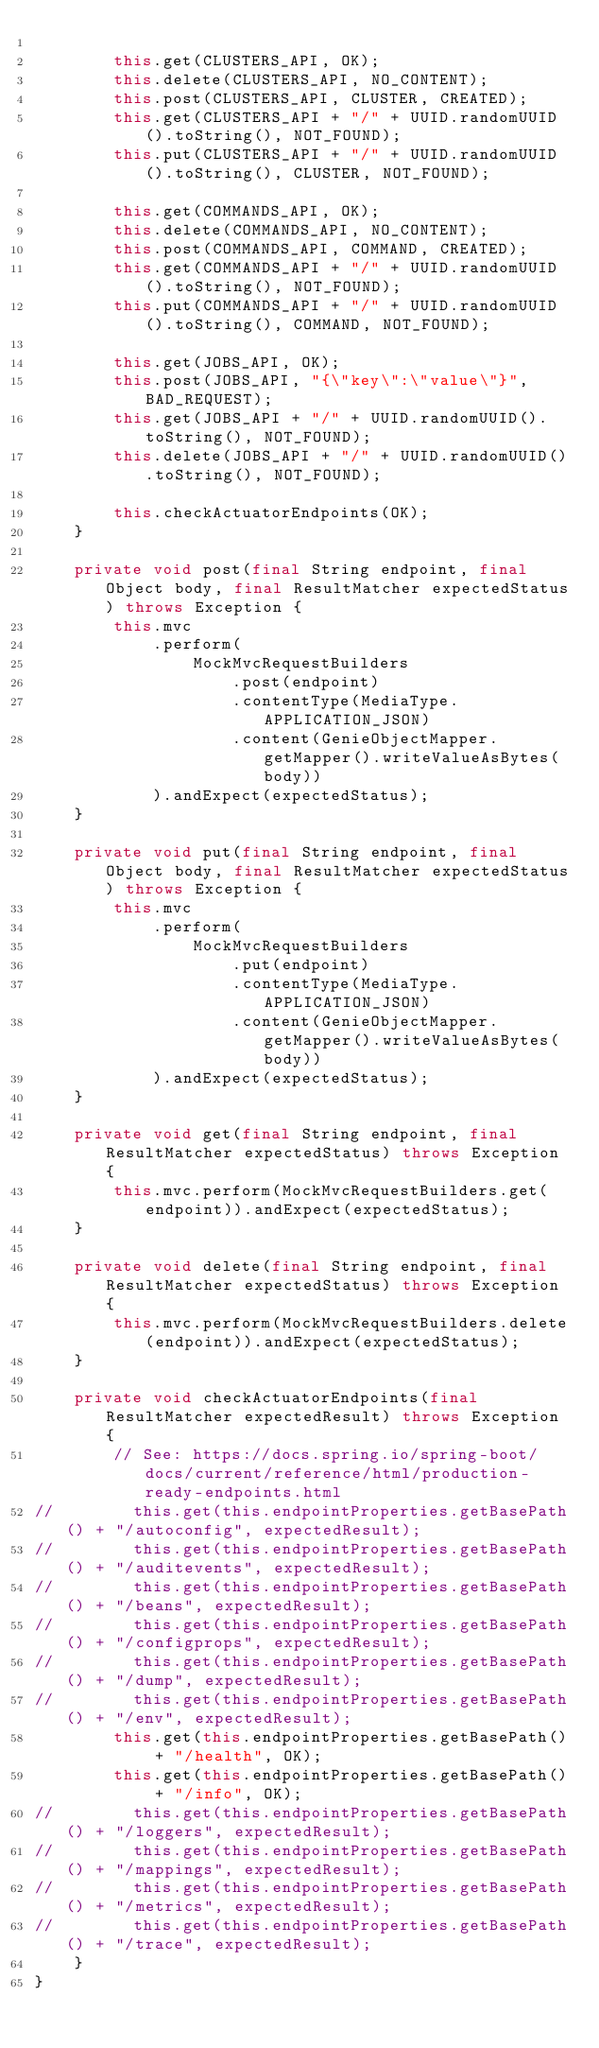<code> <loc_0><loc_0><loc_500><loc_500><_Java_>
        this.get(CLUSTERS_API, OK);
        this.delete(CLUSTERS_API, NO_CONTENT);
        this.post(CLUSTERS_API, CLUSTER, CREATED);
        this.get(CLUSTERS_API + "/" + UUID.randomUUID().toString(), NOT_FOUND);
        this.put(CLUSTERS_API + "/" + UUID.randomUUID().toString(), CLUSTER, NOT_FOUND);

        this.get(COMMANDS_API, OK);
        this.delete(COMMANDS_API, NO_CONTENT);
        this.post(COMMANDS_API, COMMAND, CREATED);
        this.get(COMMANDS_API + "/" + UUID.randomUUID().toString(), NOT_FOUND);
        this.put(COMMANDS_API + "/" + UUID.randomUUID().toString(), COMMAND, NOT_FOUND);

        this.get(JOBS_API, OK);
        this.post(JOBS_API, "{\"key\":\"value\"}", BAD_REQUEST);
        this.get(JOBS_API + "/" + UUID.randomUUID().toString(), NOT_FOUND);
        this.delete(JOBS_API + "/" + UUID.randomUUID().toString(), NOT_FOUND);

        this.checkActuatorEndpoints(OK);
    }

    private void post(final String endpoint, final Object body, final ResultMatcher expectedStatus) throws Exception {
        this.mvc
            .perform(
                MockMvcRequestBuilders
                    .post(endpoint)
                    .contentType(MediaType.APPLICATION_JSON)
                    .content(GenieObjectMapper.getMapper().writeValueAsBytes(body))
            ).andExpect(expectedStatus);
    }

    private void put(final String endpoint, final Object body, final ResultMatcher expectedStatus) throws Exception {
        this.mvc
            .perform(
                MockMvcRequestBuilders
                    .put(endpoint)
                    .contentType(MediaType.APPLICATION_JSON)
                    .content(GenieObjectMapper.getMapper().writeValueAsBytes(body))
            ).andExpect(expectedStatus);
    }

    private void get(final String endpoint, final ResultMatcher expectedStatus) throws Exception {
        this.mvc.perform(MockMvcRequestBuilders.get(endpoint)).andExpect(expectedStatus);
    }

    private void delete(final String endpoint, final ResultMatcher expectedStatus) throws Exception {
        this.mvc.perform(MockMvcRequestBuilders.delete(endpoint)).andExpect(expectedStatus);
    }

    private void checkActuatorEndpoints(final ResultMatcher expectedResult) throws Exception {
        // See: https://docs.spring.io/spring-boot/docs/current/reference/html/production-ready-endpoints.html
//        this.get(this.endpointProperties.getBasePath() + "/autoconfig", expectedResult);
//        this.get(this.endpointProperties.getBasePath() + "/auditevents", expectedResult);
//        this.get(this.endpointProperties.getBasePath() + "/beans", expectedResult);
//        this.get(this.endpointProperties.getBasePath() + "/configprops", expectedResult);
//        this.get(this.endpointProperties.getBasePath() + "/dump", expectedResult);
//        this.get(this.endpointProperties.getBasePath() + "/env", expectedResult);
        this.get(this.endpointProperties.getBasePath() + "/health", OK);
        this.get(this.endpointProperties.getBasePath() + "/info", OK);
//        this.get(this.endpointProperties.getBasePath() + "/loggers", expectedResult);
//        this.get(this.endpointProperties.getBasePath() + "/mappings", expectedResult);
//        this.get(this.endpointProperties.getBasePath() + "/metrics", expectedResult);
//        this.get(this.endpointProperties.getBasePath() + "/trace", expectedResult);
    }
}
</code> 